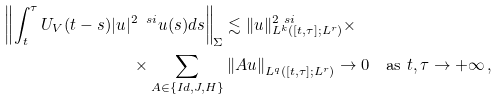<formula> <loc_0><loc_0><loc_500><loc_500>\left \| \int _ { t } ^ { \tau } U _ { V } ( t - s ) | u | ^ { 2 \ s i } u ( s ) d s \right \| _ { \Sigma } & \lesssim \| u \| _ { L ^ { k } ( [ t , \tau ] ; L ^ { r } ) } ^ { 2 \ s i } \times \\ \times \sum _ { A \in \{ I d , J , H \} } & \left \| A u \right \| _ { L ^ { q } ( [ t , \tau ] ; L ^ { r } ) } \to 0 \quad \text {as } t , \tau \to + \infty \, ,</formula> 